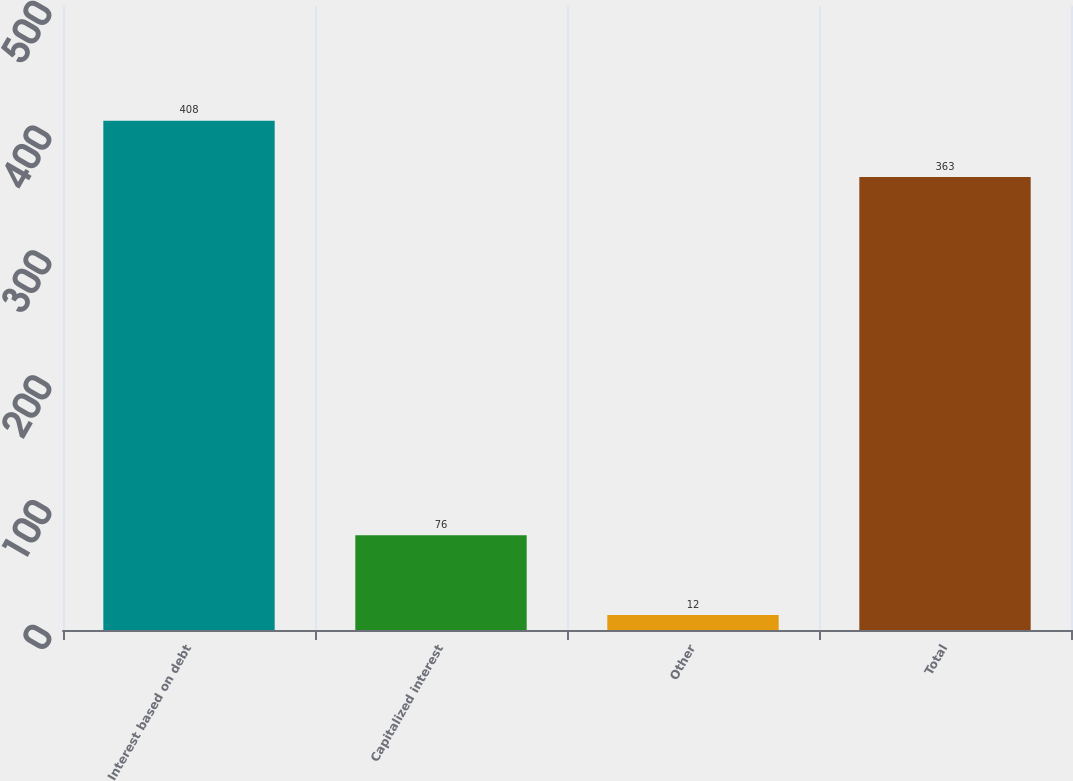Convert chart to OTSL. <chart><loc_0><loc_0><loc_500><loc_500><bar_chart><fcel>Interest based on debt<fcel>Capitalized interest<fcel>Other<fcel>Total<nl><fcel>408<fcel>76<fcel>12<fcel>363<nl></chart> 